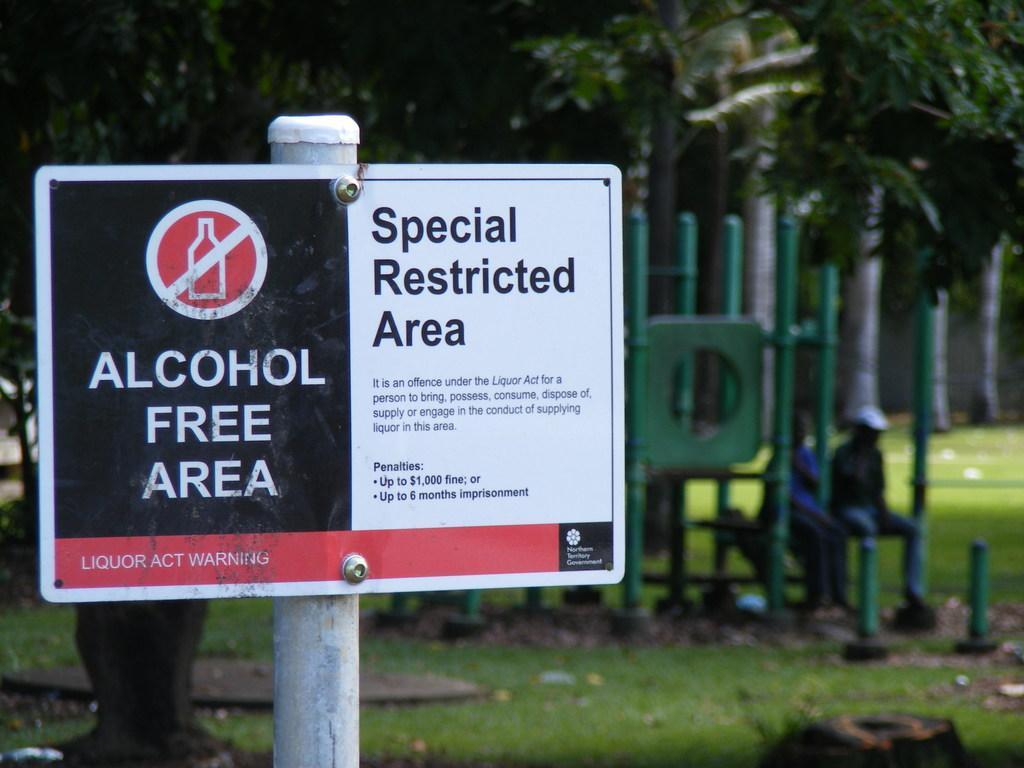Describe this image in one or two sentences. In this picture I can see there is a pole with a precaution board and there are two people sitting, there is grass and trees in the backdrop and it is blurred. 